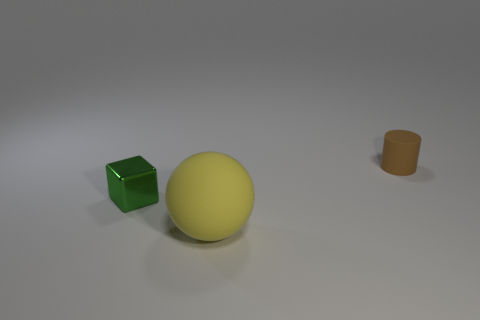Add 1 big metallic balls. How many objects exist? 4 Subtract all cubes. How many objects are left? 2 Add 3 big yellow rubber spheres. How many big yellow rubber spheres are left? 4 Add 3 green cubes. How many green cubes exist? 4 Subtract 1 yellow spheres. How many objects are left? 2 Subtract all big blue metallic cubes. Subtract all brown matte things. How many objects are left? 2 